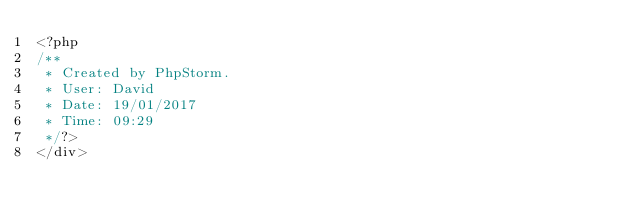Convert code to text. <code><loc_0><loc_0><loc_500><loc_500><_PHP_><?php
/**
 * Created by PhpStorm.
 * User: David
 * Date: 19/01/2017
 * Time: 09:29
 */?>
</div>
</code> 